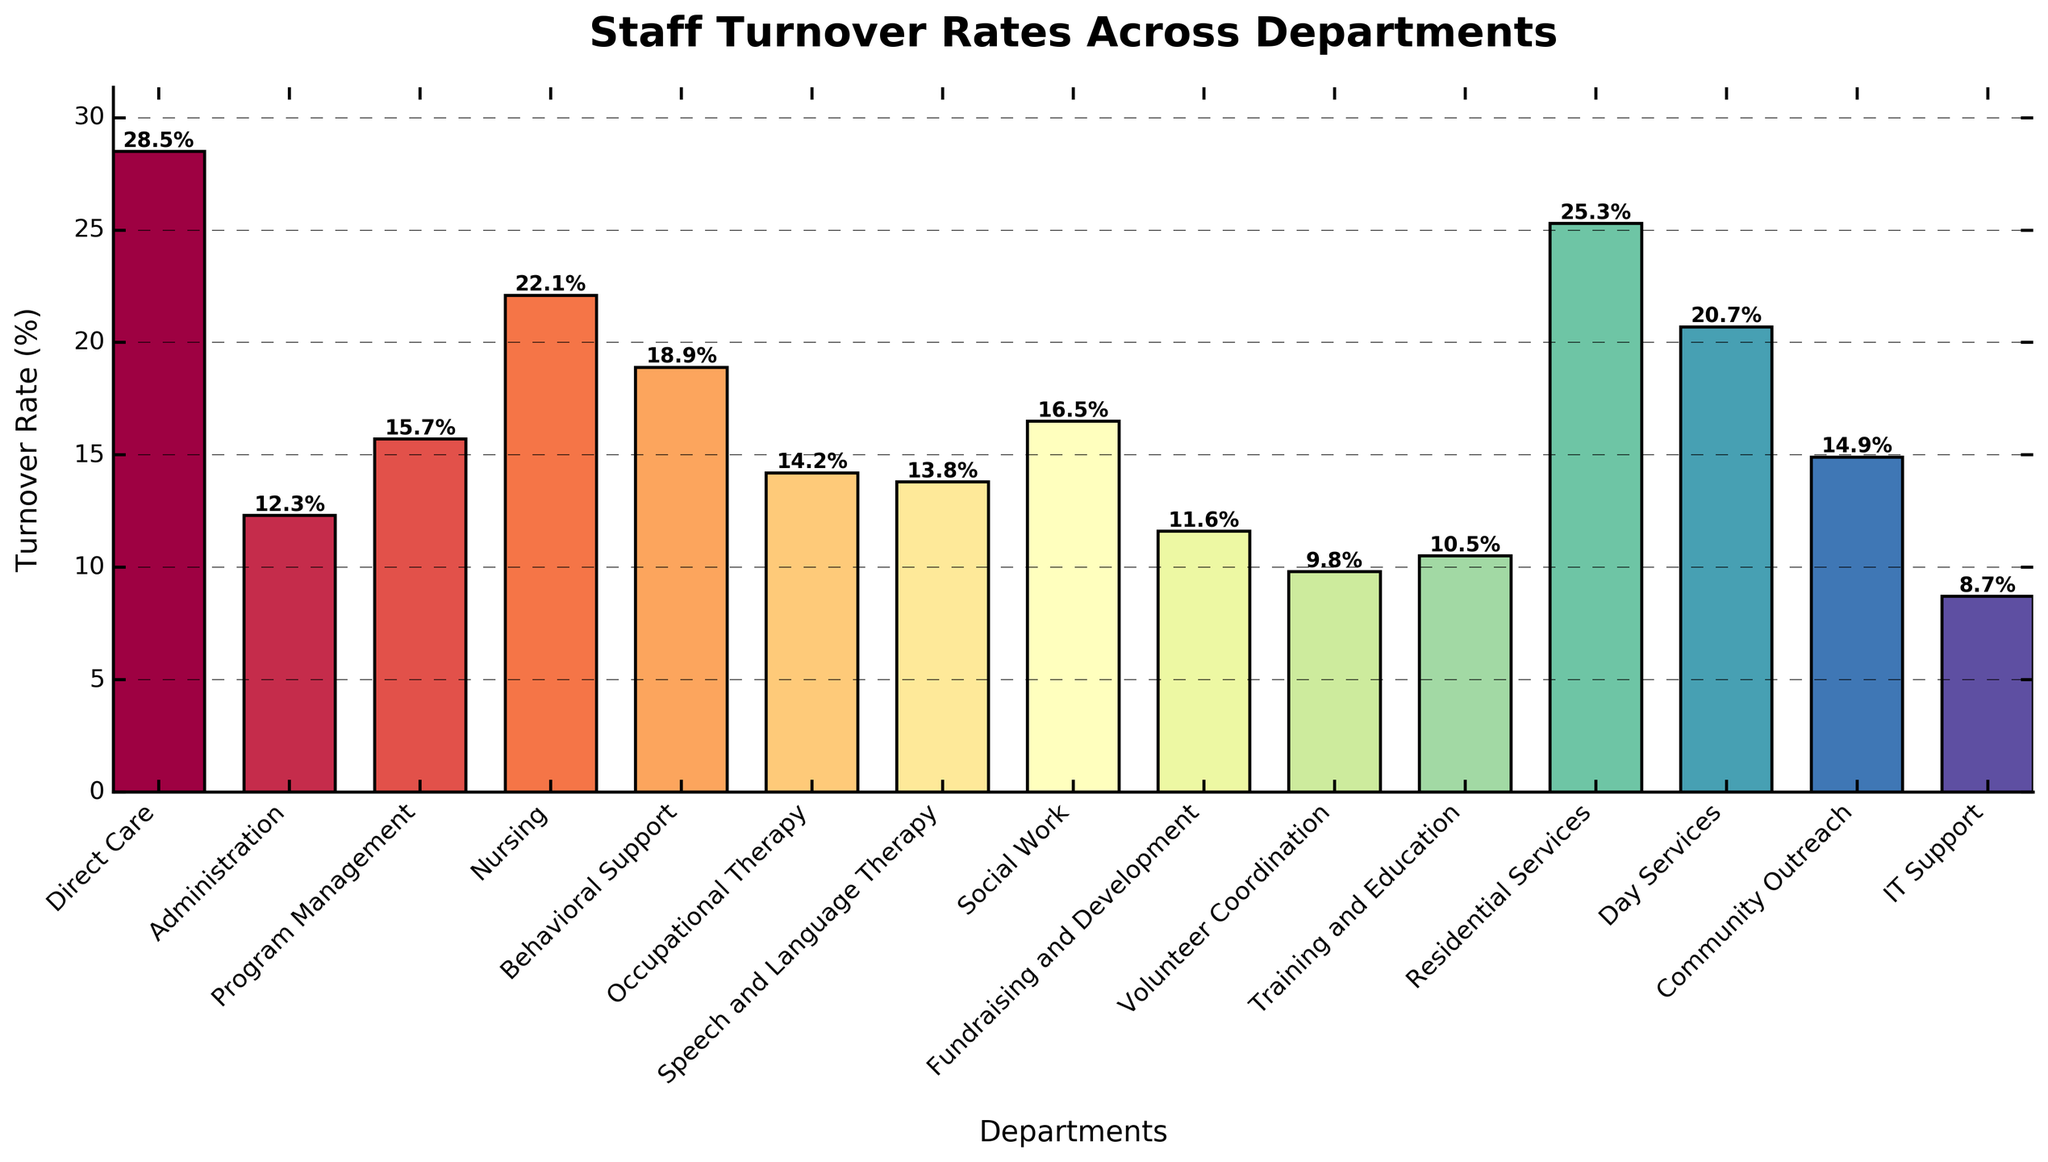What is the department with the highest turnover rate? The bar representing Direct Care is the tallest and has the highest percentage displayed.
Answer: Direct Care Which department has a lower turnover rate, Social Work or Occupational Therapy? By comparing the heights of the bars for Social Work and Occupational Therapy, Social Work's turnover rate is 16.5% while Occupational Therapy's is 14.2%.
Answer: Occupational Therapy What is the difference in turnover rate between Direct Care and Nursing? The turnover rate for Direct Care is 28.5% and for Nursing is 22.1%. The difference is 28.5% - 22.1% = 6.4%.
Answer: 6.4% How many departments have a turnover rate above 20%? Visually inspect the bars for departments with heights that indicate a turnover rate above 20%. These are Direct Care (28.5%), Nursing (22.1%), Residential Services (25.3%), and Day Services (20.7%), totaling 4 departments.
Answer: 4 Which department has the lowest turnover rate? The IT Support bar is the shortest and has the lowest percentage displayed.
Answer: IT Support What are the turnover rates for the departments categorized under Therapy (Occupational Therapy, Speech and Language Therapy)? Occupational Therapy has a turnover rate of 14.2%, and Speech and Language Therapy has a rate of 13.8%.
Answer: 14.2% and 13.8% Which department has a higher turnover rate, Program Management or Behavioral Support? Comparing the bar heights, Behavioral Support has a higher rate (18.9%) than Program Management (15.7%).
Answer: Behavioral Support If Training and Education and Volunteer Coordination were combined into a single department, what would be the average turnover rate for the combined department? Add the turnover rates for both departments (10.5% for Training and Education, and 9.8% for Volunteer Coordination) then divide by 2: (10.5 + 9.8) / 2 = 10.15%.
Answer: 10.15% What is the total turnover rate for Administration, Program Management, and Fundraising and Development combined? Sum the turnover rates for the three departments: 12.3% (Administration) + 15.7% (Program Management) + 11.6% (Fundraising and Development) = 39.6%.
Answer: 39.6% Which departments have a turnover rate between 10% and 15%? Inspect the bars for turnover rates within the range of 10% to 15%. These are Administration (12.3%), Occupational Therapy (14.2%), Speech and Language Therapy (13.8%), and Training and Education (10.5%).
Answer: Administration, Occupational Therapy, Speech and Language Therapy, Training and Education 